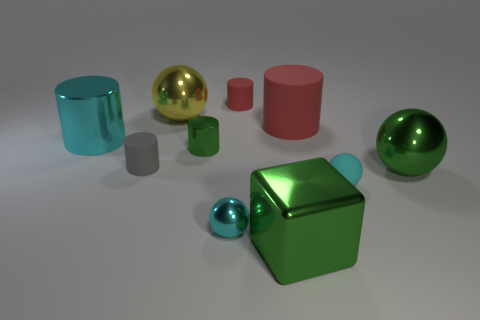Subtract all shiny cylinders. How many cylinders are left? 3 Subtract 1 spheres. How many spheres are left? 3 Subtract all green balls. How many balls are left? 3 Subtract all balls. How many objects are left? 6 Subtract all green cylinders. Subtract all green balls. How many cylinders are left? 4 Subtract all cyan cubes. How many brown balls are left? 0 Subtract all metal cylinders. Subtract all small green cylinders. How many objects are left? 7 Add 6 big shiny cylinders. How many big shiny cylinders are left? 7 Add 5 large green shiny spheres. How many large green shiny spheres exist? 6 Subtract 1 gray cylinders. How many objects are left? 9 